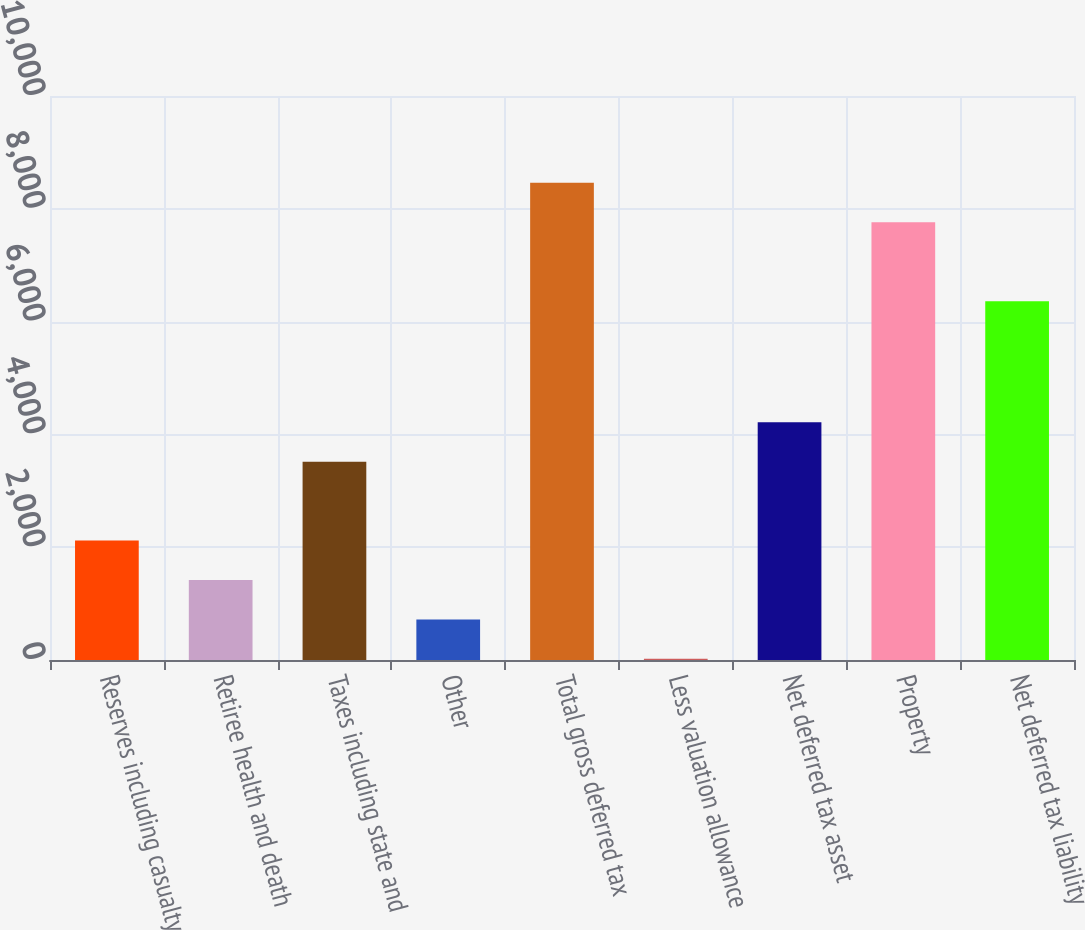<chart> <loc_0><loc_0><loc_500><loc_500><bar_chart><fcel>Reserves including casualty<fcel>Retiree health and death<fcel>Taxes including state and<fcel>Other<fcel>Total gross deferred tax<fcel>Less valuation allowance<fcel>Net deferred tax asset<fcel>Property<fcel>Net deferred tax liability<nl><fcel>2117.7<fcel>1418.8<fcel>3515.5<fcel>719.9<fcel>8459.7<fcel>21<fcel>4214.4<fcel>7760.8<fcel>6363<nl></chart> 